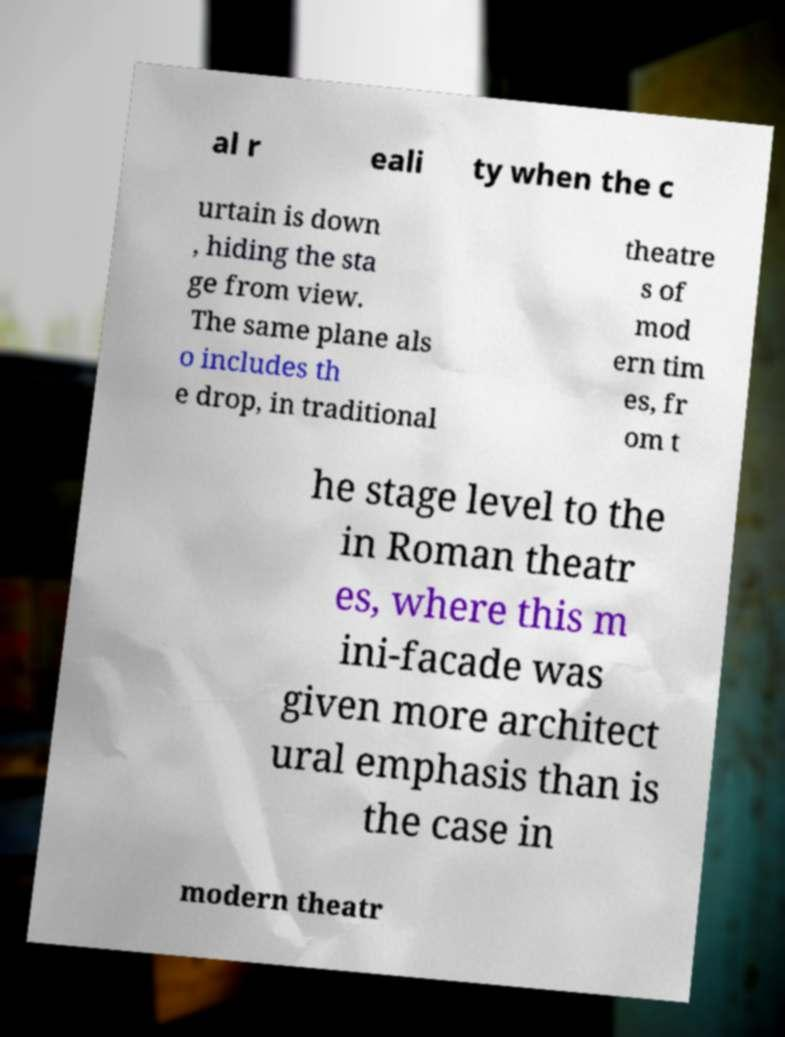Please identify and transcribe the text found in this image. al r eali ty when the c urtain is down , hiding the sta ge from view. The same plane als o includes th e drop, in traditional theatre s of mod ern tim es, fr om t he stage level to the in Roman theatr es, where this m ini-facade was given more architect ural emphasis than is the case in modern theatr 